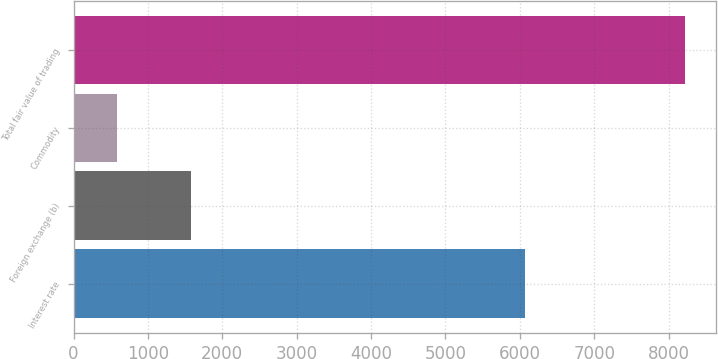Convert chart to OTSL. <chart><loc_0><loc_0><loc_500><loc_500><bar_chart><fcel>Interest rate<fcel>Foreign exchange (b)<fcel>Commodity<fcel>Total fair value of trading<nl><fcel>6064<fcel>1577<fcel>586<fcel>8227<nl></chart> 